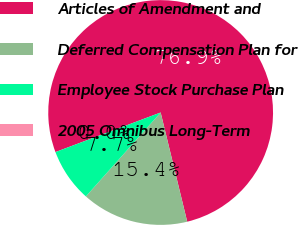Convert chart. <chart><loc_0><loc_0><loc_500><loc_500><pie_chart><fcel>Articles of Amendment and<fcel>Deferred Compensation Plan for<fcel>Employee Stock Purchase Plan<fcel>2005 Omnibus Long-Term<nl><fcel>76.92%<fcel>15.38%<fcel>7.69%<fcel>0.0%<nl></chart> 